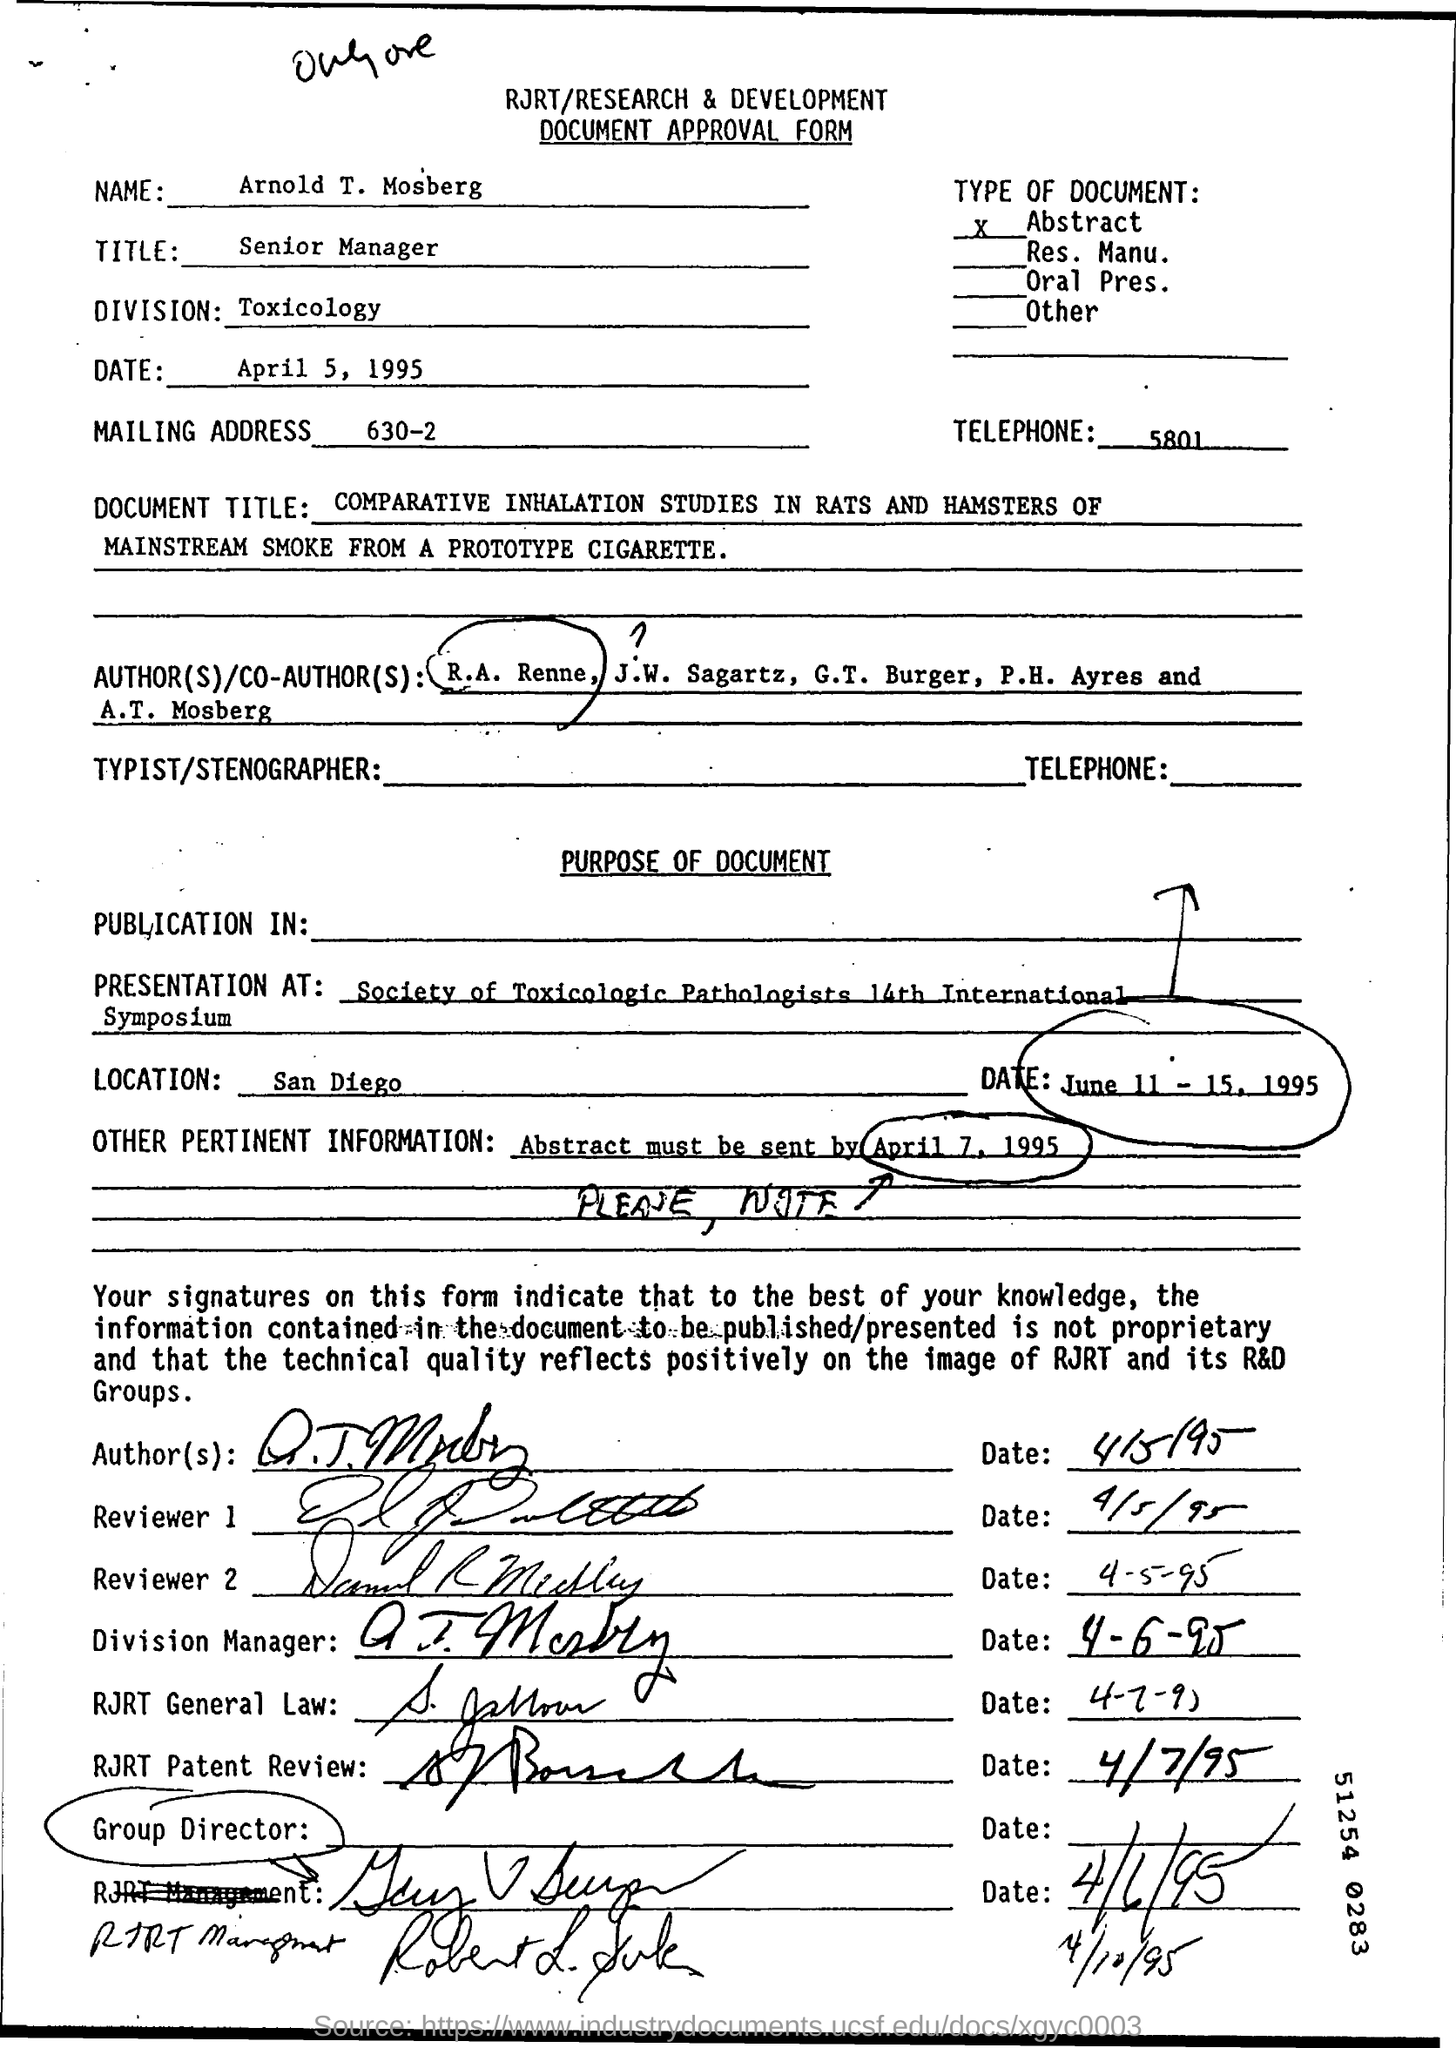Identify some key points in this picture. The approval form was approved on April 5, 1995. The name in the Document Approval form is "Arnold T. Mosberg. Arnold is a Senior Manager. 